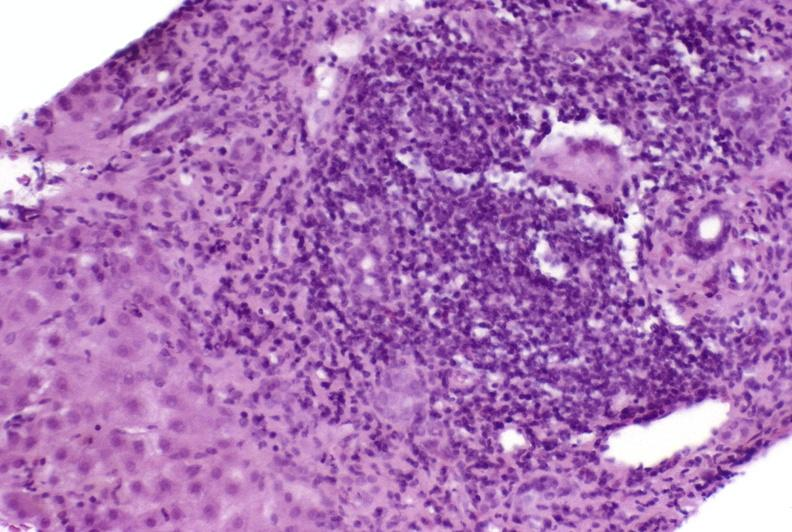s artery present?
Answer the question using a single word or phrase. No 